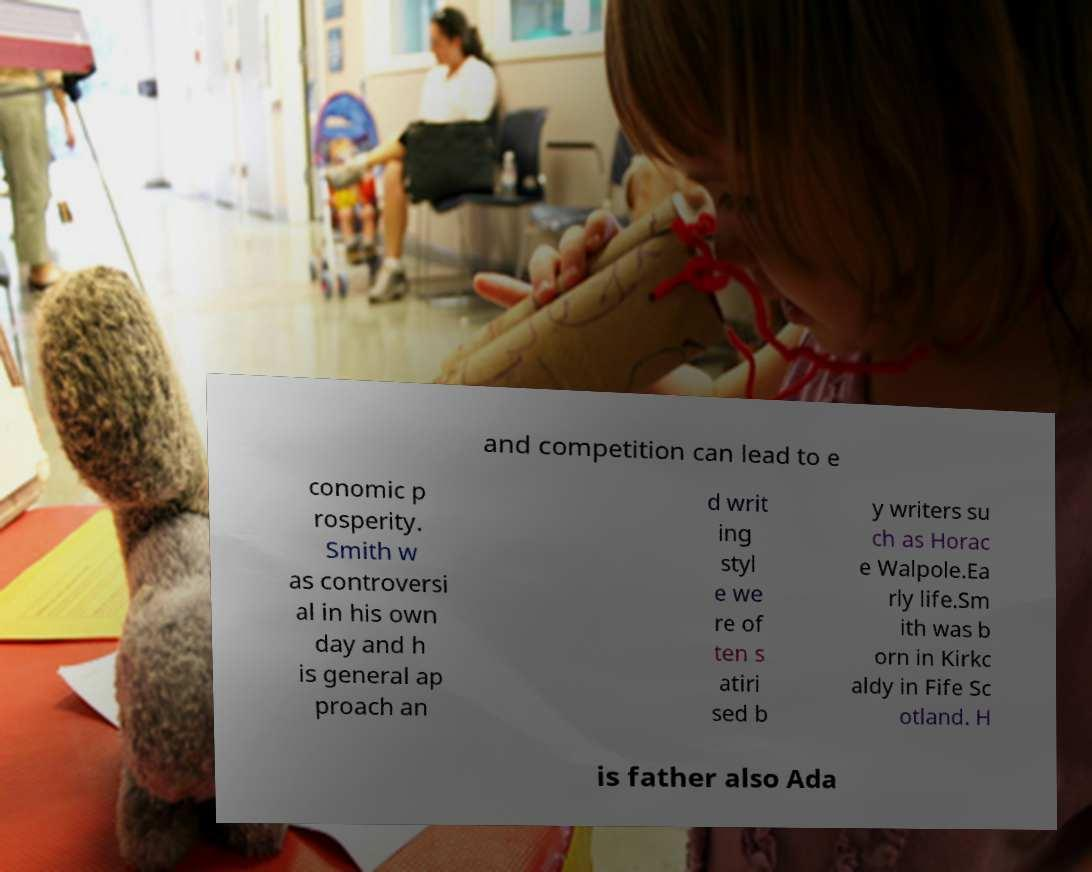Can you read and provide the text displayed in the image?This photo seems to have some interesting text. Can you extract and type it out for me? and competition can lead to e conomic p rosperity. Smith w as controversi al in his own day and h is general ap proach an d writ ing styl e we re of ten s atiri sed b y writers su ch as Horac e Walpole.Ea rly life.Sm ith was b orn in Kirkc aldy in Fife Sc otland. H is father also Ada 